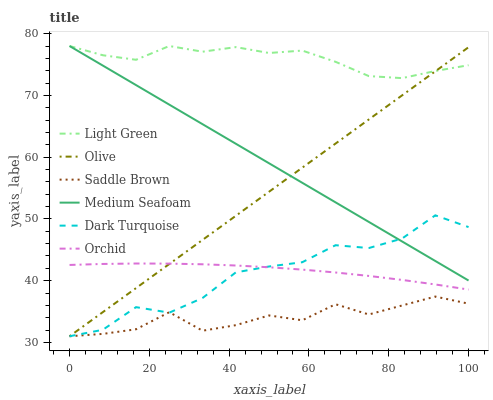Does Saddle Brown have the minimum area under the curve?
Answer yes or no. Yes. Does Light Green have the maximum area under the curve?
Answer yes or no. Yes. Does Medium Seafoam have the minimum area under the curve?
Answer yes or no. No. Does Medium Seafoam have the maximum area under the curve?
Answer yes or no. No. Is Olive the smoothest?
Answer yes or no. Yes. Is Dark Turquoise the roughest?
Answer yes or no. Yes. Is Medium Seafoam the smoothest?
Answer yes or no. No. Is Medium Seafoam the roughest?
Answer yes or no. No. Does Dark Turquoise have the lowest value?
Answer yes or no. Yes. Does Medium Seafoam have the lowest value?
Answer yes or no. No. Does Light Green have the highest value?
Answer yes or no. Yes. Does Olive have the highest value?
Answer yes or no. No. Is Dark Turquoise less than Light Green?
Answer yes or no. Yes. Is Light Green greater than Orchid?
Answer yes or no. Yes. Does Dark Turquoise intersect Orchid?
Answer yes or no. Yes. Is Dark Turquoise less than Orchid?
Answer yes or no. No. Is Dark Turquoise greater than Orchid?
Answer yes or no. No. Does Dark Turquoise intersect Light Green?
Answer yes or no. No. 